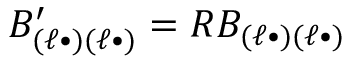Convert formula to latex. <formula><loc_0><loc_0><loc_500><loc_500>B _ { ( \ell \bullet ) ( \ell \bullet ) } ^ { \prime } = R B _ { ( \ell \bullet ) ( \ell \bullet ) }</formula> 